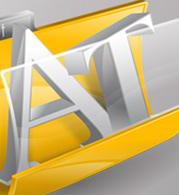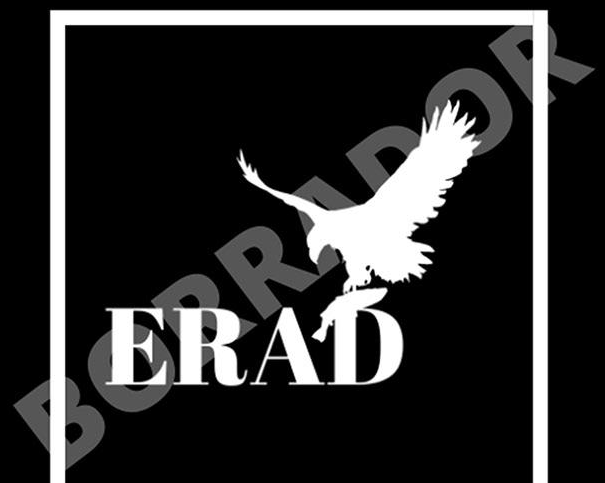What text is displayed in these images sequentially, separated by a semicolon? AT; BORRADOR 